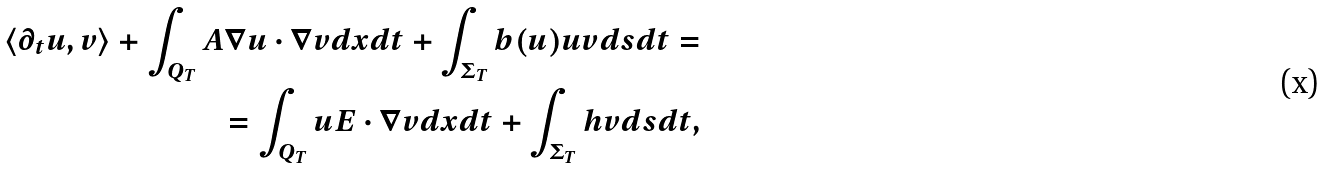Convert formula to latex. <formula><loc_0><loc_0><loc_500><loc_500>\langle \partial _ { t } u , v \rangle + \int _ { Q _ { T } } A \nabla u \cdot \nabla v d x d t + \int _ { \Sigma _ { T } } b ( u ) u v d s d t = \\ = \int _ { Q _ { T } } u { E } \cdot \nabla v d x d t + \int _ { \Sigma _ { T } } h v d s d t ,</formula> 